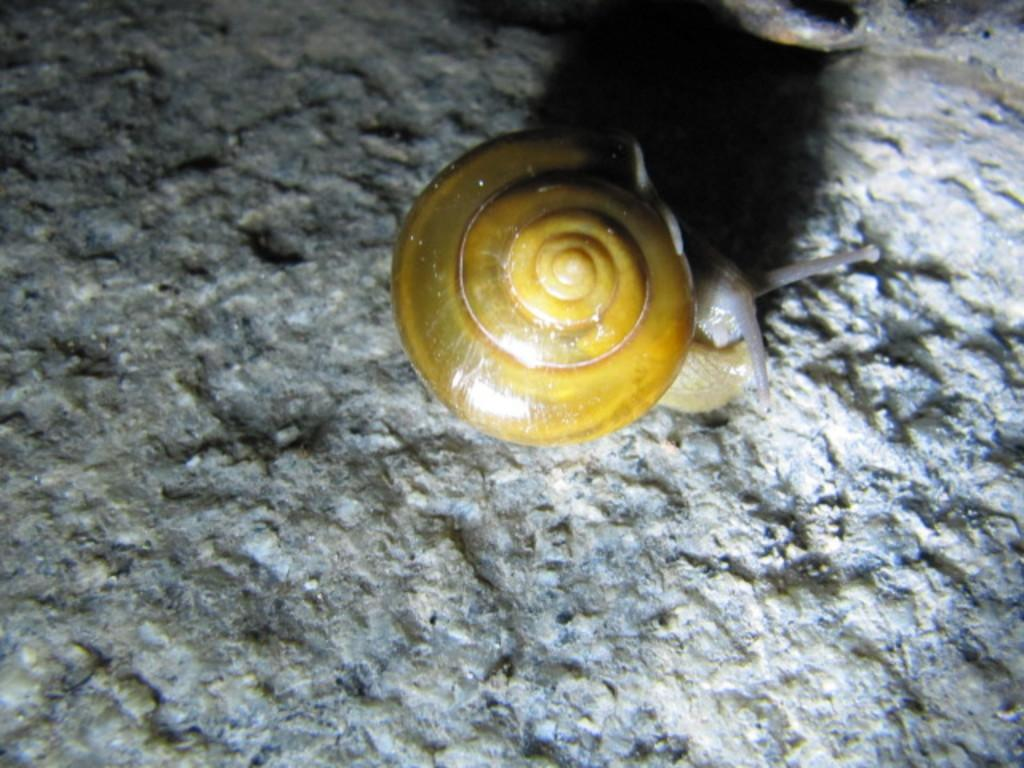What type of animal can be seen in the image? There is a snail in the image. What is the snail doing in the image? The snail is coming out of a snail shell. What is located beside the snail? There is an object beside the snail. What type of whip is being used to hit the cactus in the image? There is no whip or cactus present in the image; it features a snail coming out of its shell. 